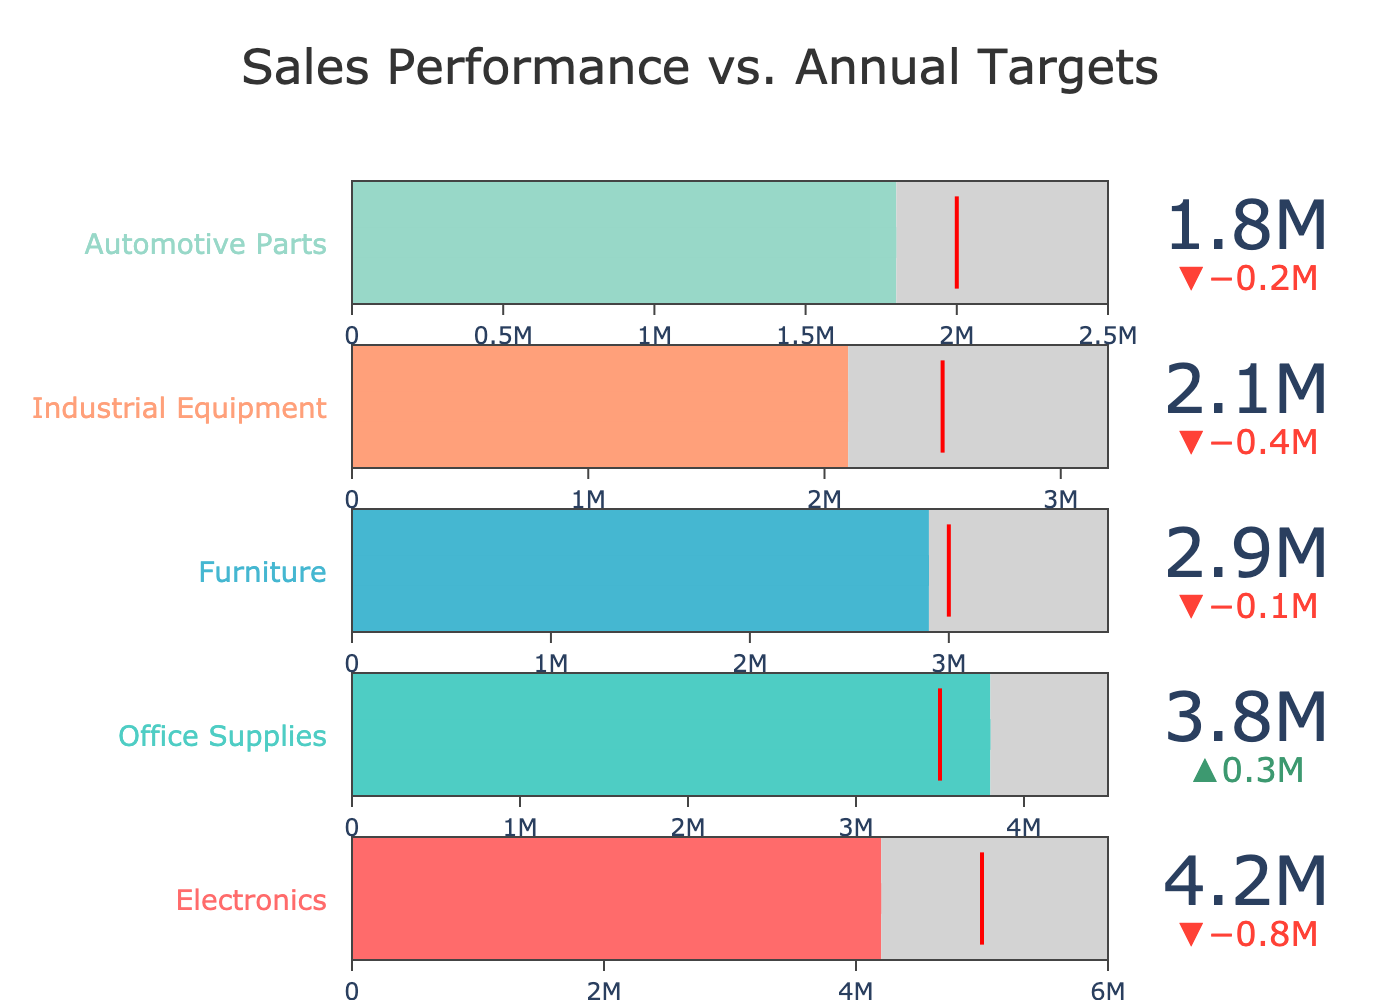What's the title of the chart? The title of the chart is positioned at the top center. Titles in charts indicate the general overview of what the chart is about. By looking at the chart, the title reads "Sales Performance vs. Annual Targets".
Answer: Sales Performance vs. Annual Targets How many product categories are displayed in the chart? To determine the number of product categories, count each distinct bullet chart within the figure. Five separate bullet charts are shown, representing five distinct product categories.
Answer: 5 Which product category has the highest actual sales? From the provided data, by looking at the bullet charts, the one with the longest bar represents the highest actual sales. Electronics has an actual sales figure of 4,200,000, which is the highest among the categories.
Answer: Electronics Did Office Supplies achieve its target sales? To determine if Office Supplies met its target, compare its actual sales to the target marker. Office Supplies has actual sales of 3,800,000 and a target of 3,500,000. The actual sales exceed the target.
Answer: Yes Which product category fell short of its target by the largest margin? To find the category with the largest shortfall, examine the delta values of each category where the actual sales are less than the target. Industrial Equipment’s actual sales are 2,100,000, with a target of 2,500,000, making it fall short by 400,000—the largest shortfall compared to other categories.
Answer: Industrial Equipment What is the difference between the actual sales and the target for Furniture? The actual sales for Furniture are 2,900,000, and the target is 3,000,000. Subtracting these values, 3,000,000 - 2,900,000, gives a difference of 100,000.
Answer: 100,000 By how much did Automotive Parts fall short of its target? The actual sales of Automotive Parts are 1,800,000 while the target is 2,000,000. The shortfall is calculated by subtracting 1,800,000 from 2,000,000, resulting in a shortfall of 200,000.
Answer: 200,000 Which product category exceeded its target by the smallest margin? Among the categories that exceeded their targets, compare the differences where actual sales surpass the target. Office Supplies exceeded its target by 3,800,000 - 3,500,000 = 300,000, which is the smallest margin compared to others that exceeded their targets.
Answer: Office Supplies What percentage of the target did Industrial Equipment achieve? To find the percentage achieved, divide the actual sales by the target and multiply by 100. For Industrial Equipment, (2,100,000 / 2,500,000) * 100 = 84%.
Answer: 84% How do the actual sales of Electronics compare to the maximum range value on its bullet chart? The actual sales for Electronics are 4,200,000 and the maximum range is 6,000,000. Comparing these, 4,200,000 is less than 6,000,000.
Answer: Less 